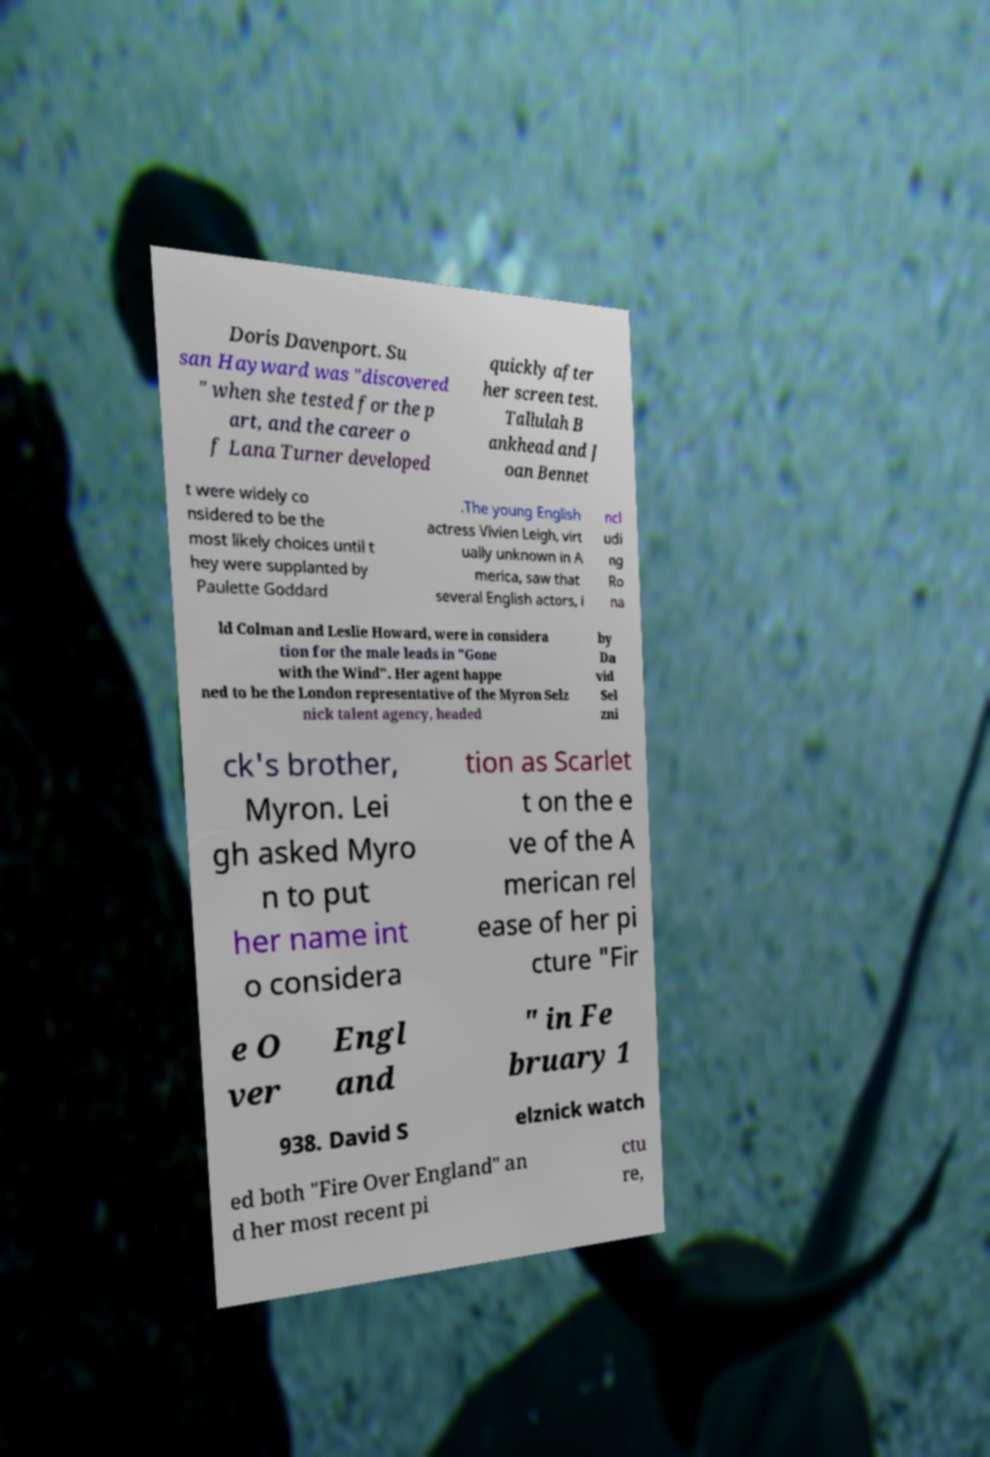Can you read and provide the text displayed in the image?This photo seems to have some interesting text. Can you extract and type it out for me? Doris Davenport. Su san Hayward was "discovered " when she tested for the p art, and the career o f Lana Turner developed quickly after her screen test. Tallulah B ankhead and J oan Bennet t were widely co nsidered to be the most likely choices until t hey were supplanted by Paulette Goddard .The young English actress Vivien Leigh, virt ually unknown in A merica, saw that several English actors, i ncl udi ng Ro na ld Colman and Leslie Howard, were in considera tion for the male leads in "Gone with the Wind". Her agent happe ned to be the London representative of the Myron Selz nick talent agency, headed by Da vid Sel zni ck's brother, Myron. Lei gh asked Myro n to put her name int o considera tion as Scarlet t on the e ve of the A merican rel ease of her pi cture "Fir e O ver Engl and " in Fe bruary 1 938. David S elznick watch ed both "Fire Over England" an d her most recent pi ctu re, 